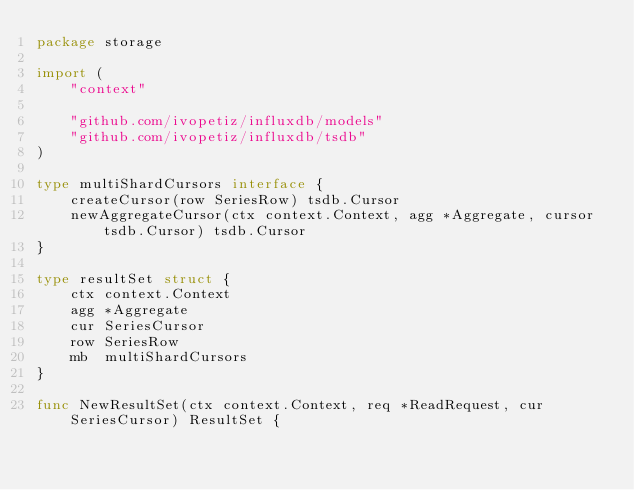Convert code to text. <code><loc_0><loc_0><loc_500><loc_500><_Go_>package storage

import (
	"context"

	"github.com/ivopetiz/influxdb/models"
	"github.com/ivopetiz/influxdb/tsdb"
)

type multiShardCursors interface {
	createCursor(row SeriesRow) tsdb.Cursor
	newAggregateCursor(ctx context.Context, agg *Aggregate, cursor tsdb.Cursor) tsdb.Cursor
}

type resultSet struct {
	ctx context.Context
	agg *Aggregate
	cur SeriesCursor
	row SeriesRow
	mb  multiShardCursors
}

func NewResultSet(ctx context.Context, req *ReadRequest, cur SeriesCursor) ResultSet {</code> 